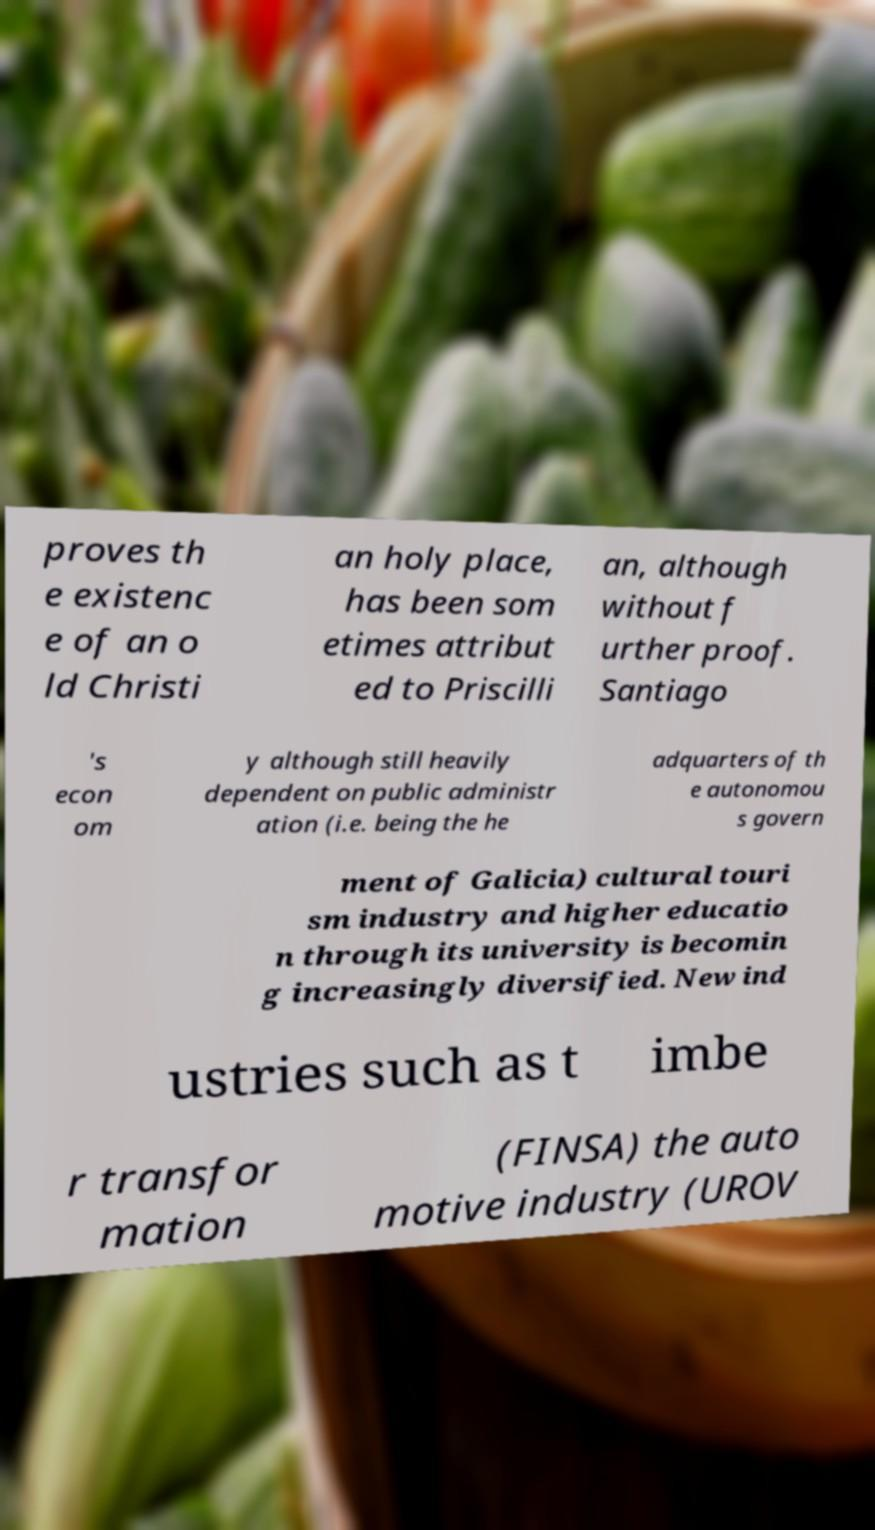There's text embedded in this image that I need extracted. Can you transcribe it verbatim? proves th e existenc e of an o ld Christi an holy place, has been som etimes attribut ed to Priscilli an, although without f urther proof. Santiago 's econ om y although still heavily dependent on public administr ation (i.e. being the he adquarters of th e autonomou s govern ment of Galicia) cultural touri sm industry and higher educatio n through its university is becomin g increasingly diversified. New ind ustries such as t imbe r transfor mation (FINSA) the auto motive industry (UROV 